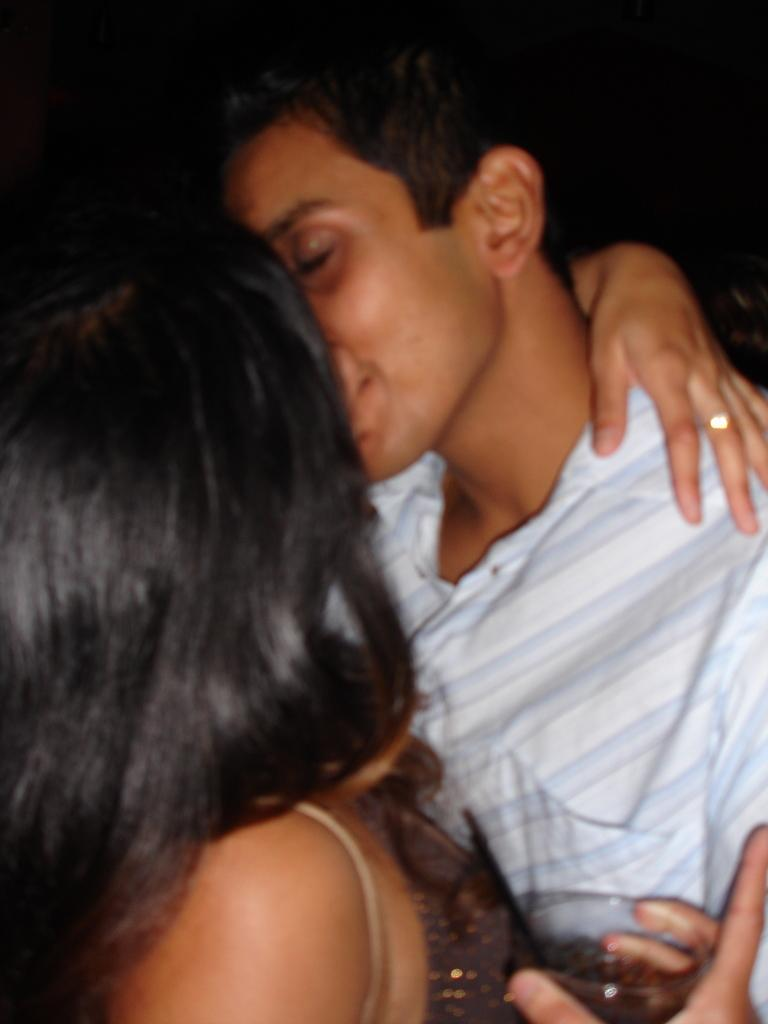How many people are in the image? There are two persons in the image. What are the two persons doing? The two persons are kissing. Can you describe what one of the persons is holding? One of the persons is holding a glass. What is the color of the background in the image? The background of the image is dark. Can you see any lakes or bodies of water in the image? There are no lakes or bodies of water visible in the image. What type of bun is being used to paint the glass in the image? There is no bun or painting activity present in the image. 